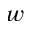<formula> <loc_0><loc_0><loc_500><loc_500>w</formula> 